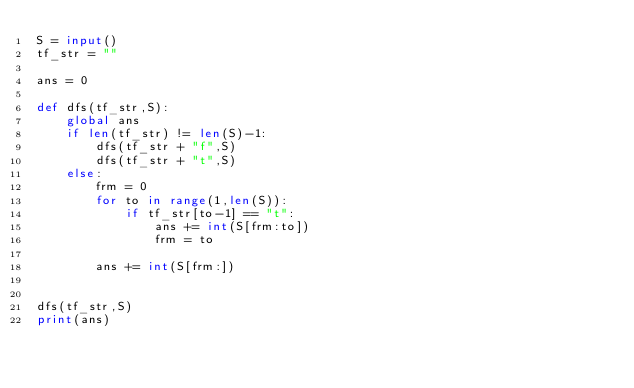<code> <loc_0><loc_0><loc_500><loc_500><_Python_>S = input()
tf_str = ""

ans = 0

def dfs(tf_str,S):
    global ans
    if len(tf_str) != len(S)-1:
        dfs(tf_str + "f",S)
        dfs(tf_str + "t",S)
    else:
        frm = 0
        for to in range(1,len(S)):
            if tf_str[to-1] == "t":
                ans += int(S[frm:to])
                frm = to
        
        ans += int(S[frm:])


dfs(tf_str,S)   
print(ans)</code> 